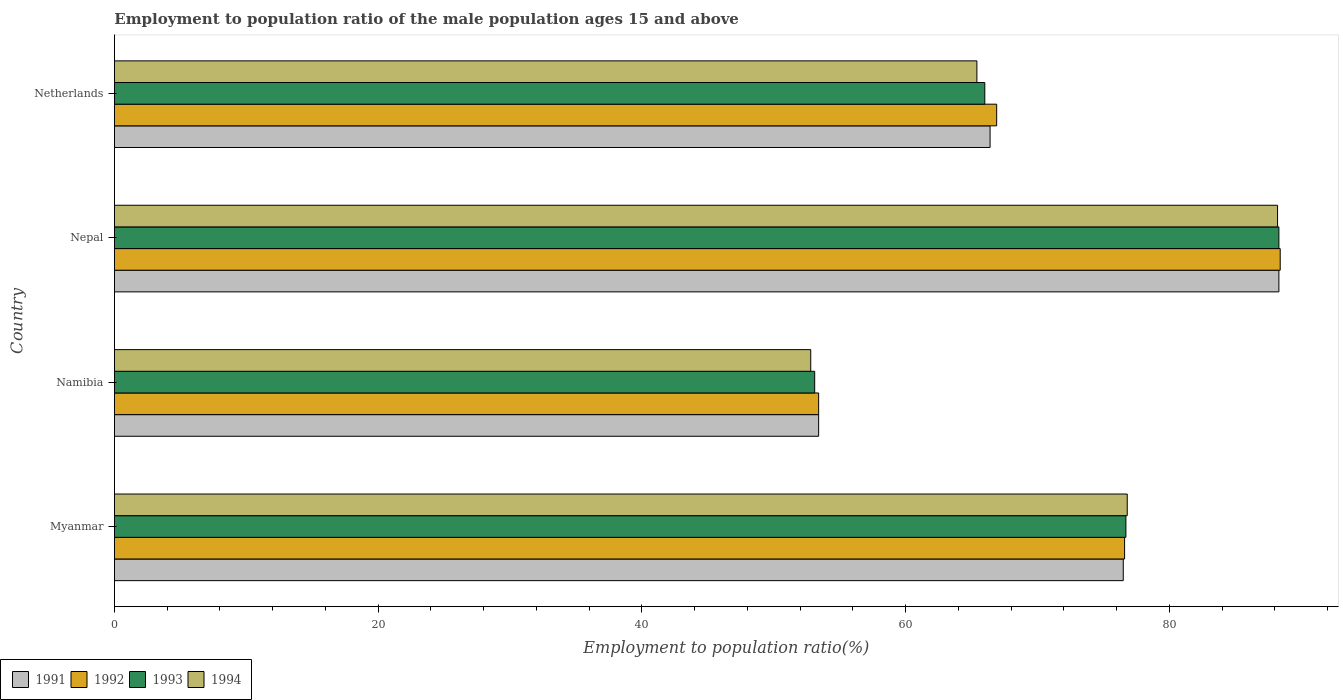How many groups of bars are there?
Make the answer very short. 4. How many bars are there on the 1st tick from the top?
Ensure brevity in your answer.  4. How many bars are there on the 4th tick from the bottom?
Ensure brevity in your answer.  4. What is the label of the 4th group of bars from the top?
Make the answer very short. Myanmar. What is the employment to population ratio in 1992 in Nepal?
Keep it short and to the point. 88.4. Across all countries, what is the maximum employment to population ratio in 1994?
Offer a terse response. 88.2. Across all countries, what is the minimum employment to population ratio in 1993?
Offer a very short reply. 53.1. In which country was the employment to population ratio in 1993 maximum?
Offer a very short reply. Nepal. In which country was the employment to population ratio in 1993 minimum?
Make the answer very short. Namibia. What is the total employment to population ratio in 1993 in the graph?
Keep it short and to the point. 284.1. What is the difference between the employment to population ratio in 1992 in Namibia and that in Nepal?
Your response must be concise. -35. What is the difference between the employment to population ratio in 1991 in Myanmar and the employment to population ratio in 1992 in Nepal?
Keep it short and to the point. -11.9. What is the average employment to population ratio in 1993 per country?
Offer a terse response. 71.02. What is the difference between the employment to population ratio in 1992 and employment to population ratio in 1991 in Nepal?
Provide a succinct answer. 0.1. What is the ratio of the employment to population ratio in 1994 in Namibia to that in Netherlands?
Your answer should be compact. 0.81. Is the difference between the employment to population ratio in 1992 in Myanmar and Nepal greater than the difference between the employment to population ratio in 1991 in Myanmar and Nepal?
Ensure brevity in your answer.  No. What is the difference between the highest and the second highest employment to population ratio in 1993?
Make the answer very short. 11.6. What is the difference between the highest and the lowest employment to population ratio in 1992?
Your answer should be very brief. 35. Is it the case that in every country, the sum of the employment to population ratio in 1993 and employment to population ratio in 1994 is greater than the sum of employment to population ratio in 1991 and employment to population ratio in 1992?
Your answer should be very brief. No. How many bars are there?
Provide a succinct answer. 16. Are all the bars in the graph horizontal?
Ensure brevity in your answer.  Yes. How many countries are there in the graph?
Give a very brief answer. 4. Are the values on the major ticks of X-axis written in scientific E-notation?
Provide a succinct answer. No. Where does the legend appear in the graph?
Make the answer very short. Bottom left. How many legend labels are there?
Provide a short and direct response. 4. How are the legend labels stacked?
Keep it short and to the point. Horizontal. What is the title of the graph?
Your response must be concise. Employment to population ratio of the male population ages 15 and above. What is the label or title of the X-axis?
Keep it short and to the point. Employment to population ratio(%). What is the label or title of the Y-axis?
Keep it short and to the point. Country. What is the Employment to population ratio(%) in 1991 in Myanmar?
Ensure brevity in your answer.  76.5. What is the Employment to population ratio(%) of 1992 in Myanmar?
Make the answer very short. 76.6. What is the Employment to population ratio(%) in 1993 in Myanmar?
Your answer should be very brief. 76.7. What is the Employment to population ratio(%) in 1994 in Myanmar?
Provide a short and direct response. 76.8. What is the Employment to population ratio(%) in 1991 in Namibia?
Ensure brevity in your answer.  53.4. What is the Employment to population ratio(%) in 1992 in Namibia?
Your answer should be very brief. 53.4. What is the Employment to population ratio(%) of 1993 in Namibia?
Provide a short and direct response. 53.1. What is the Employment to population ratio(%) of 1994 in Namibia?
Provide a succinct answer. 52.8. What is the Employment to population ratio(%) in 1991 in Nepal?
Ensure brevity in your answer.  88.3. What is the Employment to population ratio(%) in 1992 in Nepal?
Your answer should be compact. 88.4. What is the Employment to population ratio(%) of 1993 in Nepal?
Offer a terse response. 88.3. What is the Employment to population ratio(%) in 1994 in Nepal?
Give a very brief answer. 88.2. What is the Employment to population ratio(%) of 1991 in Netherlands?
Make the answer very short. 66.4. What is the Employment to population ratio(%) in 1992 in Netherlands?
Provide a short and direct response. 66.9. What is the Employment to population ratio(%) of 1994 in Netherlands?
Make the answer very short. 65.4. Across all countries, what is the maximum Employment to population ratio(%) of 1991?
Ensure brevity in your answer.  88.3. Across all countries, what is the maximum Employment to population ratio(%) of 1992?
Offer a terse response. 88.4. Across all countries, what is the maximum Employment to population ratio(%) in 1993?
Keep it short and to the point. 88.3. Across all countries, what is the maximum Employment to population ratio(%) of 1994?
Your answer should be very brief. 88.2. Across all countries, what is the minimum Employment to population ratio(%) in 1991?
Provide a succinct answer. 53.4. Across all countries, what is the minimum Employment to population ratio(%) in 1992?
Offer a terse response. 53.4. Across all countries, what is the minimum Employment to population ratio(%) in 1993?
Provide a succinct answer. 53.1. Across all countries, what is the minimum Employment to population ratio(%) in 1994?
Your answer should be very brief. 52.8. What is the total Employment to population ratio(%) of 1991 in the graph?
Make the answer very short. 284.6. What is the total Employment to population ratio(%) in 1992 in the graph?
Offer a terse response. 285.3. What is the total Employment to population ratio(%) in 1993 in the graph?
Keep it short and to the point. 284.1. What is the total Employment to population ratio(%) in 1994 in the graph?
Offer a very short reply. 283.2. What is the difference between the Employment to population ratio(%) of 1991 in Myanmar and that in Namibia?
Keep it short and to the point. 23.1. What is the difference between the Employment to population ratio(%) in 1992 in Myanmar and that in Namibia?
Provide a succinct answer. 23.2. What is the difference between the Employment to population ratio(%) in 1993 in Myanmar and that in Namibia?
Your answer should be compact. 23.6. What is the difference between the Employment to population ratio(%) in 1994 in Myanmar and that in Namibia?
Keep it short and to the point. 24. What is the difference between the Employment to population ratio(%) in 1991 in Myanmar and that in Nepal?
Provide a succinct answer. -11.8. What is the difference between the Employment to population ratio(%) in 1992 in Myanmar and that in Nepal?
Offer a terse response. -11.8. What is the difference between the Employment to population ratio(%) in 1991 in Myanmar and that in Netherlands?
Provide a short and direct response. 10.1. What is the difference between the Employment to population ratio(%) of 1992 in Myanmar and that in Netherlands?
Offer a very short reply. 9.7. What is the difference between the Employment to population ratio(%) in 1993 in Myanmar and that in Netherlands?
Your response must be concise. 10.7. What is the difference between the Employment to population ratio(%) in 1994 in Myanmar and that in Netherlands?
Provide a short and direct response. 11.4. What is the difference between the Employment to population ratio(%) of 1991 in Namibia and that in Nepal?
Offer a terse response. -34.9. What is the difference between the Employment to population ratio(%) in 1992 in Namibia and that in Nepal?
Your response must be concise. -35. What is the difference between the Employment to population ratio(%) of 1993 in Namibia and that in Nepal?
Ensure brevity in your answer.  -35.2. What is the difference between the Employment to population ratio(%) in 1994 in Namibia and that in Nepal?
Give a very brief answer. -35.4. What is the difference between the Employment to population ratio(%) in 1991 in Namibia and that in Netherlands?
Your answer should be compact. -13. What is the difference between the Employment to population ratio(%) in 1992 in Namibia and that in Netherlands?
Make the answer very short. -13.5. What is the difference between the Employment to population ratio(%) in 1993 in Namibia and that in Netherlands?
Ensure brevity in your answer.  -12.9. What is the difference between the Employment to population ratio(%) of 1991 in Nepal and that in Netherlands?
Provide a succinct answer. 21.9. What is the difference between the Employment to population ratio(%) of 1992 in Nepal and that in Netherlands?
Make the answer very short. 21.5. What is the difference between the Employment to population ratio(%) of 1993 in Nepal and that in Netherlands?
Your response must be concise. 22.3. What is the difference between the Employment to population ratio(%) in 1994 in Nepal and that in Netherlands?
Offer a terse response. 22.8. What is the difference between the Employment to population ratio(%) in 1991 in Myanmar and the Employment to population ratio(%) in 1992 in Namibia?
Provide a succinct answer. 23.1. What is the difference between the Employment to population ratio(%) of 1991 in Myanmar and the Employment to population ratio(%) of 1993 in Namibia?
Keep it short and to the point. 23.4. What is the difference between the Employment to population ratio(%) of 1991 in Myanmar and the Employment to population ratio(%) of 1994 in Namibia?
Your answer should be compact. 23.7. What is the difference between the Employment to population ratio(%) of 1992 in Myanmar and the Employment to population ratio(%) of 1993 in Namibia?
Your answer should be compact. 23.5. What is the difference between the Employment to population ratio(%) in 1992 in Myanmar and the Employment to population ratio(%) in 1994 in Namibia?
Keep it short and to the point. 23.8. What is the difference between the Employment to population ratio(%) in 1993 in Myanmar and the Employment to population ratio(%) in 1994 in Namibia?
Your response must be concise. 23.9. What is the difference between the Employment to population ratio(%) of 1991 in Myanmar and the Employment to population ratio(%) of 1992 in Nepal?
Make the answer very short. -11.9. What is the difference between the Employment to population ratio(%) of 1991 in Myanmar and the Employment to population ratio(%) of 1994 in Nepal?
Provide a short and direct response. -11.7. What is the difference between the Employment to population ratio(%) in 1991 in Myanmar and the Employment to population ratio(%) in 1993 in Netherlands?
Give a very brief answer. 10.5. What is the difference between the Employment to population ratio(%) of 1992 in Myanmar and the Employment to population ratio(%) of 1993 in Netherlands?
Your answer should be compact. 10.6. What is the difference between the Employment to population ratio(%) in 1992 in Myanmar and the Employment to population ratio(%) in 1994 in Netherlands?
Your answer should be compact. 11.2. What is the difference between the Employment to population ratio(%) in 1991 in Namibia and the Employment to population ratio(%) in 1992 in Nepal?
Provide a succinct answer. -35. What is the difference between the Employment to population ratio(%) in 1991 in Namibia and the Employment to population ratio(%) in 1993 in Nepal?
Your response must be concise. -34.9. What is the difference between the Employment to population ratio(%) of 1991 in Namibia and the Employment to population ratio(%) of 1994 in Nepal?
Your response must be concise. -34.8. What is the difference between the Employment to population ratio(%) of 1992 in Namibia and the Employment to population ratio(%) of 1993 in Nepal?
Make the answer very short. -34.9. What is the difference between the Employment to population ratio(%) in 1992 in Namibia and the Employment to population ratio(%) in 1994 in Nepal?
Your response must be concise. -34.8. What is the difference between the Employment to population ratio(%) in 1993 in Namibia and the Employment to population ratio(%) in 1994 in Nepal?
Provide a short and direct response. -35.1. What is the difference between the Employment to population ratio(%) in 1991 in Namibia and the Employment to population ratio(%) in 1994 in Netherlands?
Ensure brevity in your answer.  -12. What is the difference between the Employment to population ratio(%) in 1991 in Nepal and the Employment to population ratio(%) in 1992 in Netherlands?
Offer a very short reply. 21.4. What is the difference between the Employment to population ratio(%) of 1991 in Nepal and the Employment to population ratio(%) of 1993 in Netherlands?
Offer a very short reply. 22.3. What is the difference between the Employment to population ratio(%) in 1991 in Nepal and the Employment to population ratio(%) in 1994 in Netherlands?
Keep it short and to the point. 22.9. What is the difference between the Employment to population ratio(%) in 1992 in Nepal and the Employment to population ratio(%) in 1993 in Netherlands?
Provide a short and direct response. 22.4. What is the difference between the Employment to population ratio(%) in 1992 in Nepal and the Employment to population ratio(%) in 1994 in Netherlands?
Your answer should be compact. 23. What is the difference between the Employment to population ratio(%) of 1993 in Nepal and the Employment to population ratio(%) of 1994 in Netherlands?
Provide a succinct answer. 22.9. What is the average Employment to population ratio(%) in 1991 per country?
Your response must be concise. 71.15. What is the average Employment to population ratio(%) in 1992 per country?
Offer a terse response. 71.33. What is the average Employment to population ratio(%) of 1993 per country?
Make the answer very short. 71.03. What is the average Employment to population ratio(%) of 1994 per country?
Ensure brevity in your answer.  70.8. What is the difference between the Employment to population ratio(%) of 1991 and Employment to population ratio(%) of 1992 in Myanmar?
Give a very brief answer. -0.1. What is the difference between the Employment to population ratio(%) of 1991 and Employment to population ratio(%) of 1993 in Myanmar?
Give a very brief answer. -0.2. What is the difference between the Employment to population ratio(%) of 1992 and Employment to population ratio(%) of 1993 in Myanmar?
Your response must be concise. -0.1. What is the difference between the Employment to population ratio(%) of 1992 and Employment to population ratio(%) of 1994 in Myanmar?
Your response must be concise. -0.2. What is the difference between the Employment to population ratio(%) in 1993 and Employment to population ratio(%) in 1994 in Myanmar?
Make the answer very short. -0.1. What is the difference between the Employment to population ratio(%) of 1993 and Employment to population ratio(%) of 1994 in Namibia?
Provide a short and direct response. 0.3. What is the difference between the Employment to population ratio(%) of 1991 and Employment to population ratio(%) of 1992 in Nepal?
Your answer should be compact. -0.1. What is the difference between the Employment to population ratio(%) in 1991 and Employment to population ratio(%) in 1994 in Nepal?
Your answer should be compact. 0.1. What is the difference between the Employment to population ratio(%) in 1992 and Employment to population ratio(%) in 1993 in Nepal?
Offer a terse response. 0.1. What is the difference between the Employment to population ratio(%) of 1993 and Employment to population ratio(%) of 1994 in Nepal?
Keep it short and to the point. 0.1. What is the difference between the Employment to population ratio(%) of 1991 and Employment to population ratio(%) of 1992 in Netherlands?
Make the answer very short. -0.5. What is the difference between the Employment to population ratio(%) in 1991 and Employment to population ratio(%) in 1993 in Netherlands?
Offer a terse response. 0.4. What is the difference between the Employment to population ratio(%) of 1993 and Employment to population ratio(%) of 1994 in Netherlands?
Offer a very short reply. 0.6. What is the ratio of the Employment to population ratio(%) of 1991 in Myanmar to that in Namibia?
Keep it short and to the point. 1.43. What is the ratio of the Employment to population ratio(%) of 1992 in Myanmar to that in Namibia?
Provide a succinct answer. 1.43. What is the ratio of the Employment to population ratio(%) of 1993 in Myanmar to that in Namibia?
Make the answer very short. 1.44. What is the ratio of the Employment to population ratio(%) in 1994 in Myanmar to that in Namibia?
Ensure brevity in your answer.  1.45. What is the ratio of the Employment to population ratio(%) in 1991 in Myanmar to that in Nepal?
Your answer should be very brief. 0.87. What is the ratio of the Employment to population ratio(%) in 1992 in Myanmar to that in Nepal?
Ensure brevity in your answer.  0.87. What is the ratio of the Employment to population ratio(%) in 1993 in Myanmar to that in Nepal?
Ensure brevity in your answer.  0.87. What is the ratio of the Employment to population ratio(%) in 1994 in Myanmar to that in Nepal?
Ensure brevity in your answer.  0.87. What is the ratio of the Employment to population ratio(%) of 1991 in Myanmar to that in Netherlands?
Offer a very short reply. 1.15. What is the ratio of the Employment to population ratio(%) in 1992 in Myanmar to that in Netherlands?
Your answer should be compact. 1.15. What is the ratio of the Employment to population ratio(%) of 1993 in Myanmar to that in Netherlands?
Your response must be concise. 1.16. What is the ratio of the Employment to population ratio(%) in 1994 in Myanmar to that in Netherlands?
Your response must be concise. 1.17. What is the ratio of the Employment to population ratio(%) of 1991 in Namibia to that in Nepal?
Offer a very short reply. 0.6. What is the ratio of the Employment to population ratio(%) in 1992 in Namibia to that in Nepal?
Your answer should be compact. 0.6. What is the ratio of the Employment to population ratio(%) in 1993 in Namibia to that in Nepal?
Offer a terse response. 0.6. What is the ratio of the Employment to population ratio(%) of 1994 in Namibia to that in Nepal?
Make the answer very short. 0.6. What is the ratio of the Employment to population ratio(%) of 1991 in Namibia to that in Netherlands?
Offer a terse response. 0.8. What is the ratio of the Employment to population ratio(%) in 1992 in Namibia to that in Netherlands?
Offer a terse response. 0.8. What is the ratio of the Employment to population ratio(%) of 1993 in Namibia to that in Netherlands?
Your response must be concise. 0.8. What is the ratio of the Employment to population ratio(%) of 1994 in Namibia to that in Netherlands?
Keep it short and to the point. 0.81. What is the ratio of the Employment to population ratio(%) in 1991 in Nepal to that in Netherlands?
Your response must be concise. 1.33. What is the ratio of the Employment to population ratio(%) of 1992 in Nepal to that in Netherlands?
Your response must be concise. 1.32. What is the ratio of the Employment to population ratio(%) of 1993 in Nepal to that in Netherlands?
Your response must be concise. 1.34. What is the ratio of the Employment to population ratio(%) in 1994 in Nepal to that in Netherlands?
Offer a terse response. 1.35. What is the difference between the highest and the second highest Employment to population ratio(%) of 1991?
Give a very brief answer. 11.8. What is the difference between the highest and the lowest Employment to population ratio(%) in 1991?
Ensure brevity in your answer.  34.9. What is the difference between the highest and the lowest Employment to population ratio(%) in 1992?
Make the answer very short. 35. What is the difference between the highest and the lowest Employment to population ratio(%) in 1993?
Provide a short and direct response. 35.2. What is the difference between the highest and the lowest Employment to population ratio(%) in 1994?
Your answer should be compact. 35.4. 